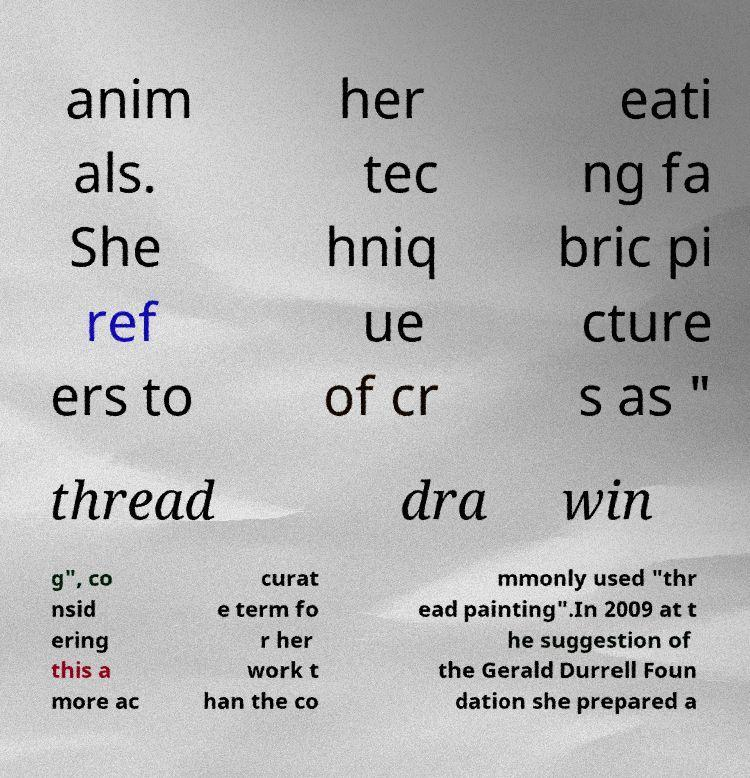Could you assist in decoding the text presented in this image and type it out clearly? anim als. She ref ers to her tec hniq ue of cr eati ng fa bric pi cture s as " thread dra win g", co nsid ering this a more ac curat e term fo r her work t han the co mmonly used "thr ead painting".In 2009 at t he suggestion of the Gerald Durrell Foun dation she prepared a 